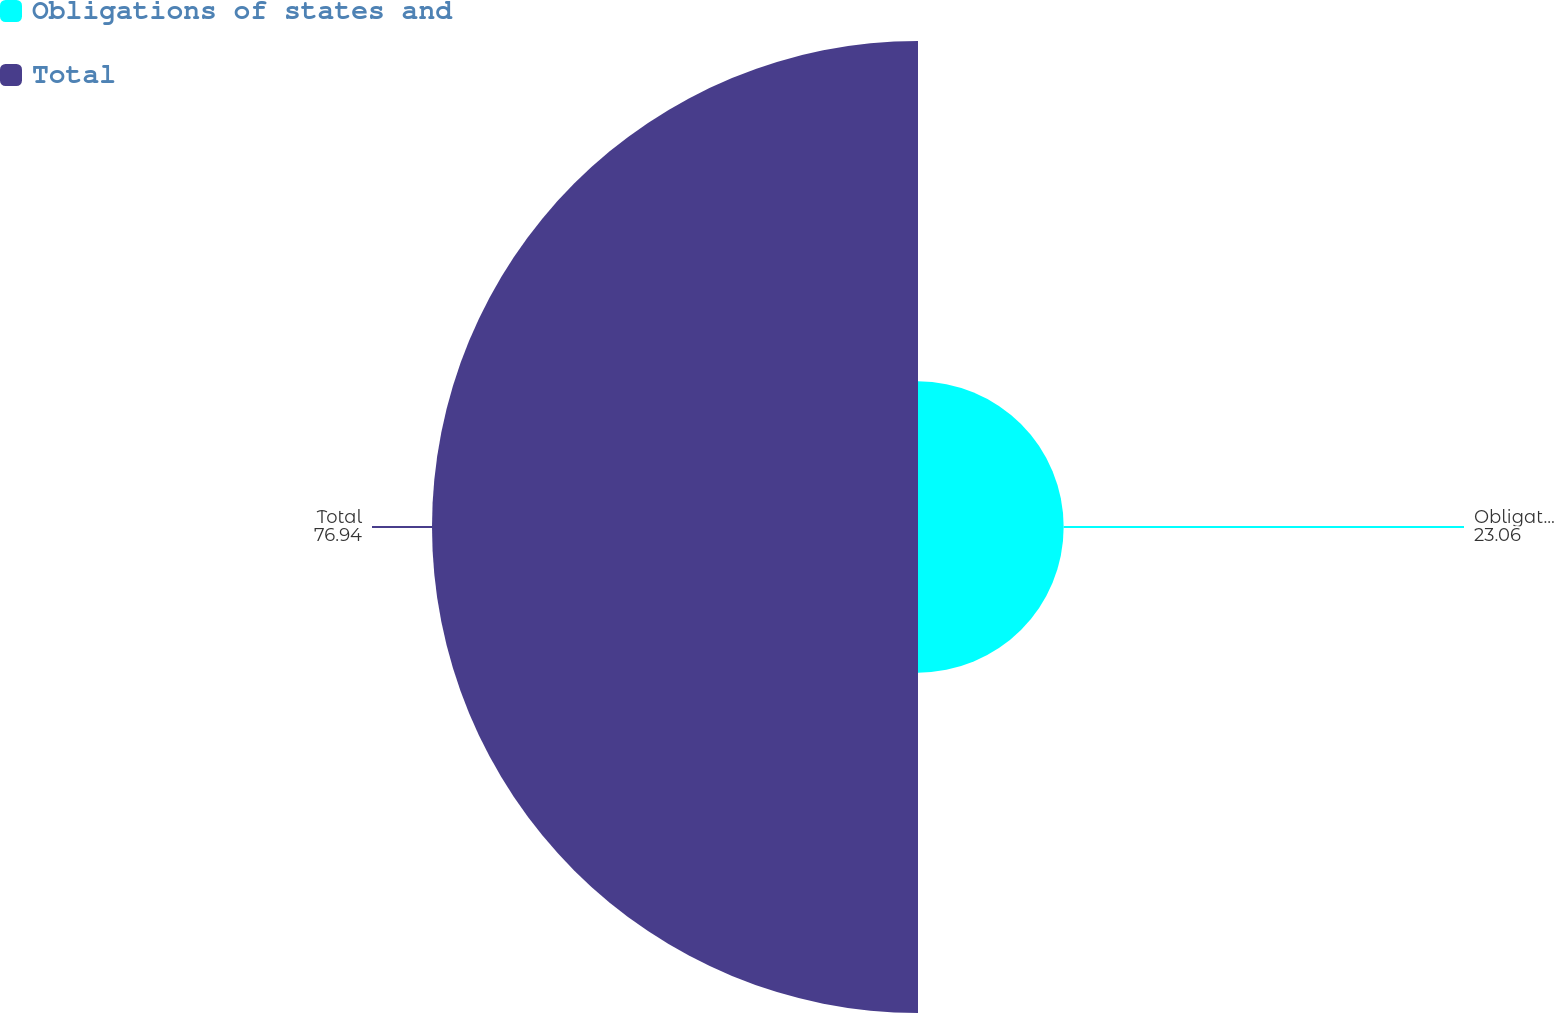<chart> <loc_0><loc_0><loc_500><loc_500><pie_chart><fcel>Obligations of states and<fcel>Total<nl><fcel>23.06%<fcel>76.94%<nl></chart> 